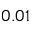<formula> <loc_0><loc_0><loc_500><loc_500>0 . 0 1</formula> 